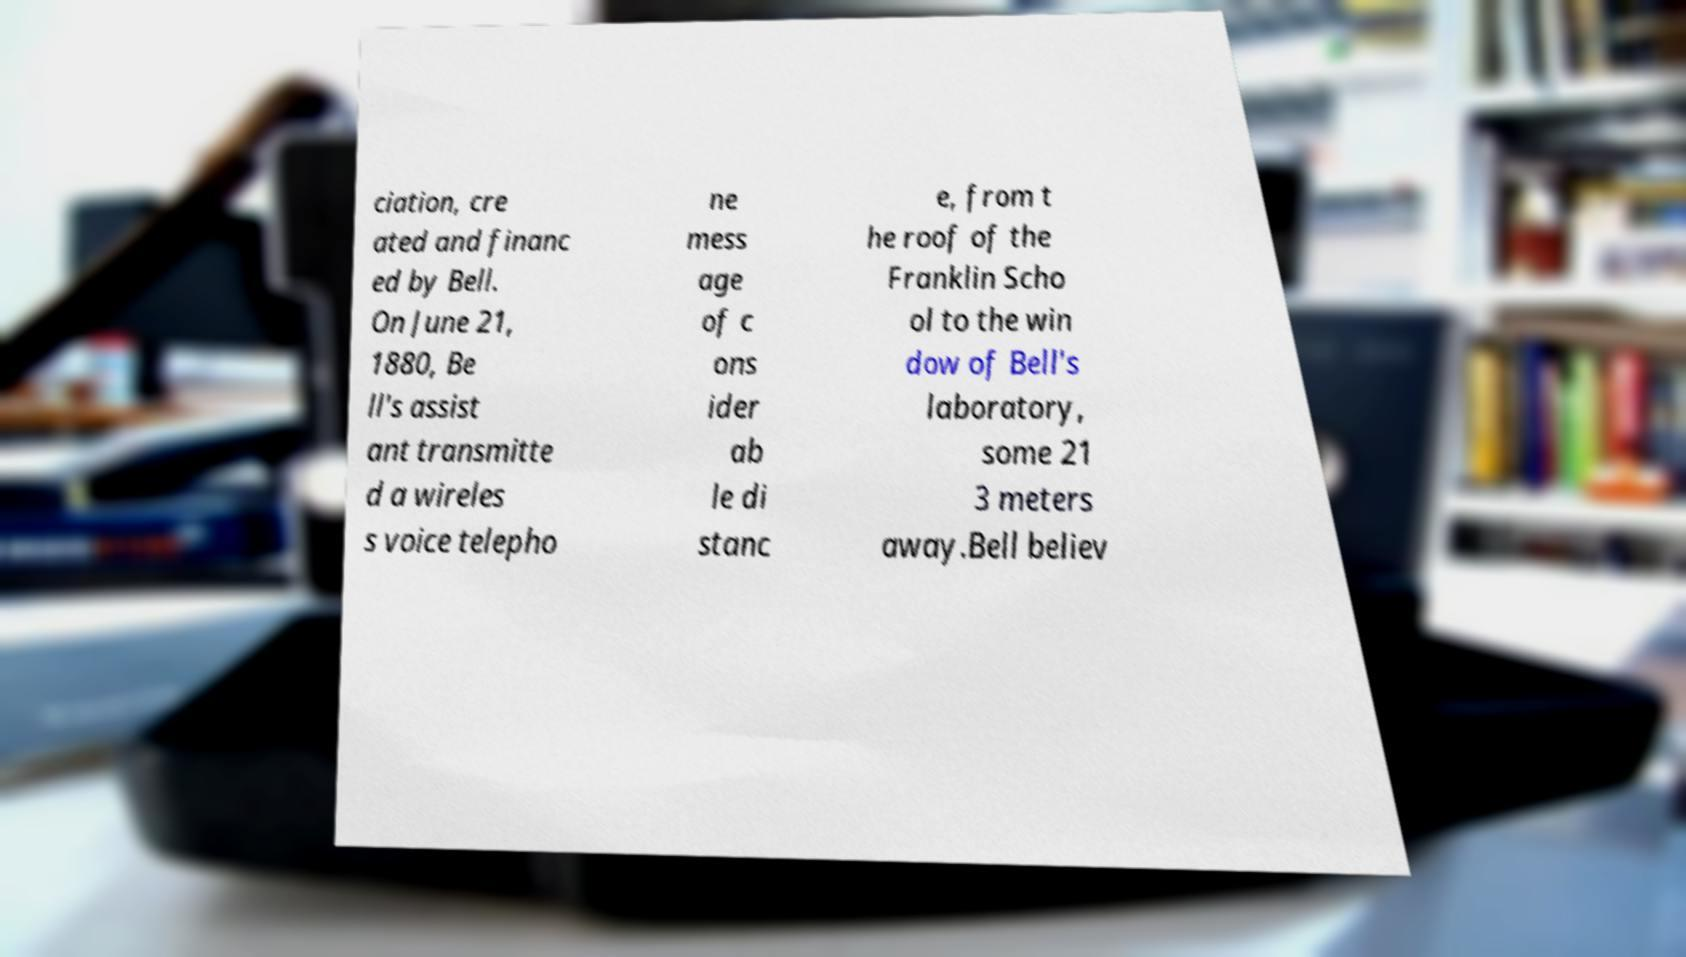What messages or text are displayed in this image? I need them in a readable, typed format. ciation, cre ated and financ ed by Bell. On June 21, 1880, Be ll's assist ant transmitte d a wireles s voice telepho ne mess age of c ons ider ab le di stanc e, from t he roof of the Franklin Scho ol to the win dow of Bell's laboratory, some 21 3 meters away.Bell believ 